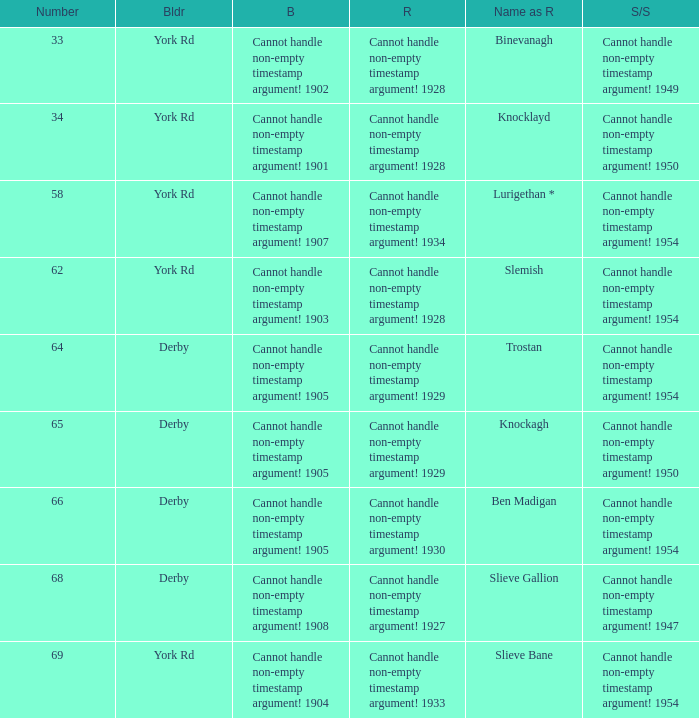Which Scrapped/Sold has a Name as rebuilt of trostan? Cannot handle non-empty timestamp argument! 1954. 